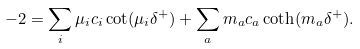Convert formula to latex. <formula><loc_0><loc_0><loc_500><loc_500>- 2 = \sum _ { i } \mu _ { i } c _ { i } \cot ( \mu _ { i } \delta ^ { + } ) + \sum _ { a } m _ { a } c _ { a } \coth ( m _ { a } \delta ^ { + } ) .</formula> 